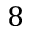Convert formula to latex. <formula><loc_0><loc_0><loc_500><loc_500>8</formula> 